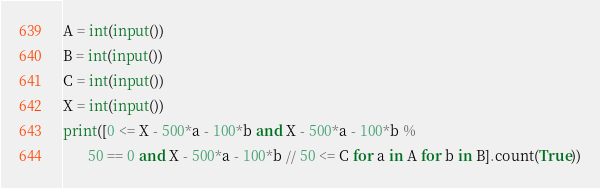<code> <loc_0><loc_0><loc_500><loc_500><_Python_>A = int(input())
B = int(input())
C = int(input())
X = int(input())
print([0 <= X - 500*a - 100*b and X - 500*a - 100*b %
       50 == 0 and X - 500*a - 100*b // 50 <= C for a in A for b in B].count(True))
</code> 